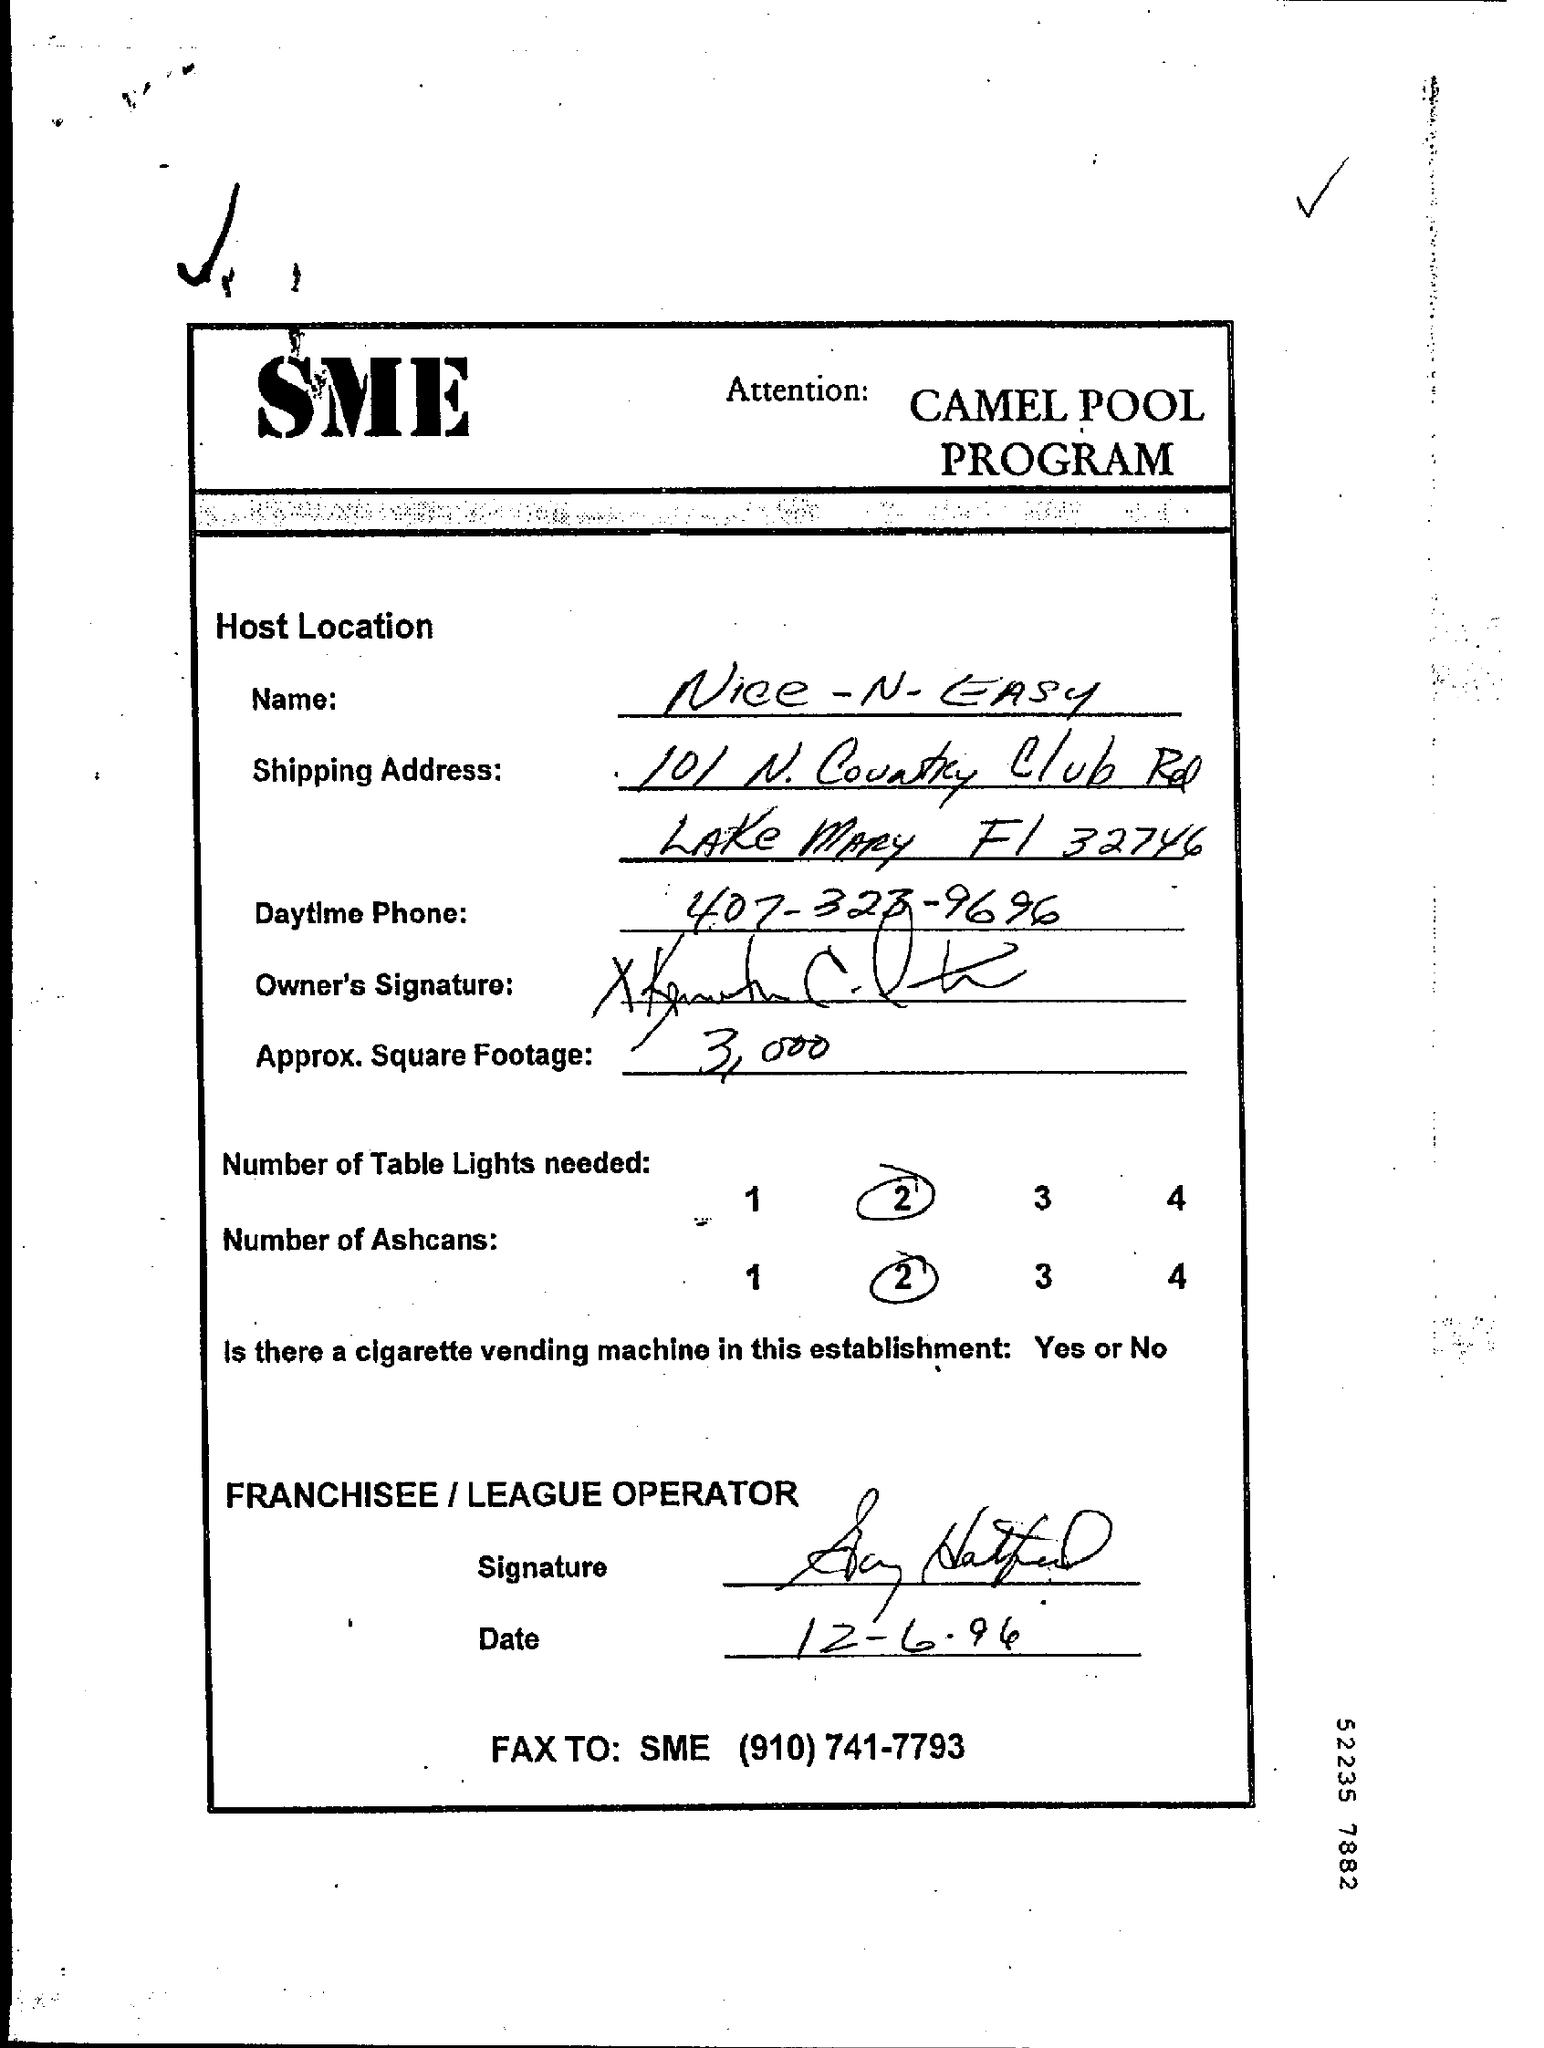What is the program?
Your answer should be compact. Camel pool program. What is the name given?
Make the answer very short. Nice - n - easy. How many Ashcans are needed?
Offer a terse response. 2. What is the Fax number given?
Give a very brief answer. (910) 741-7793. 